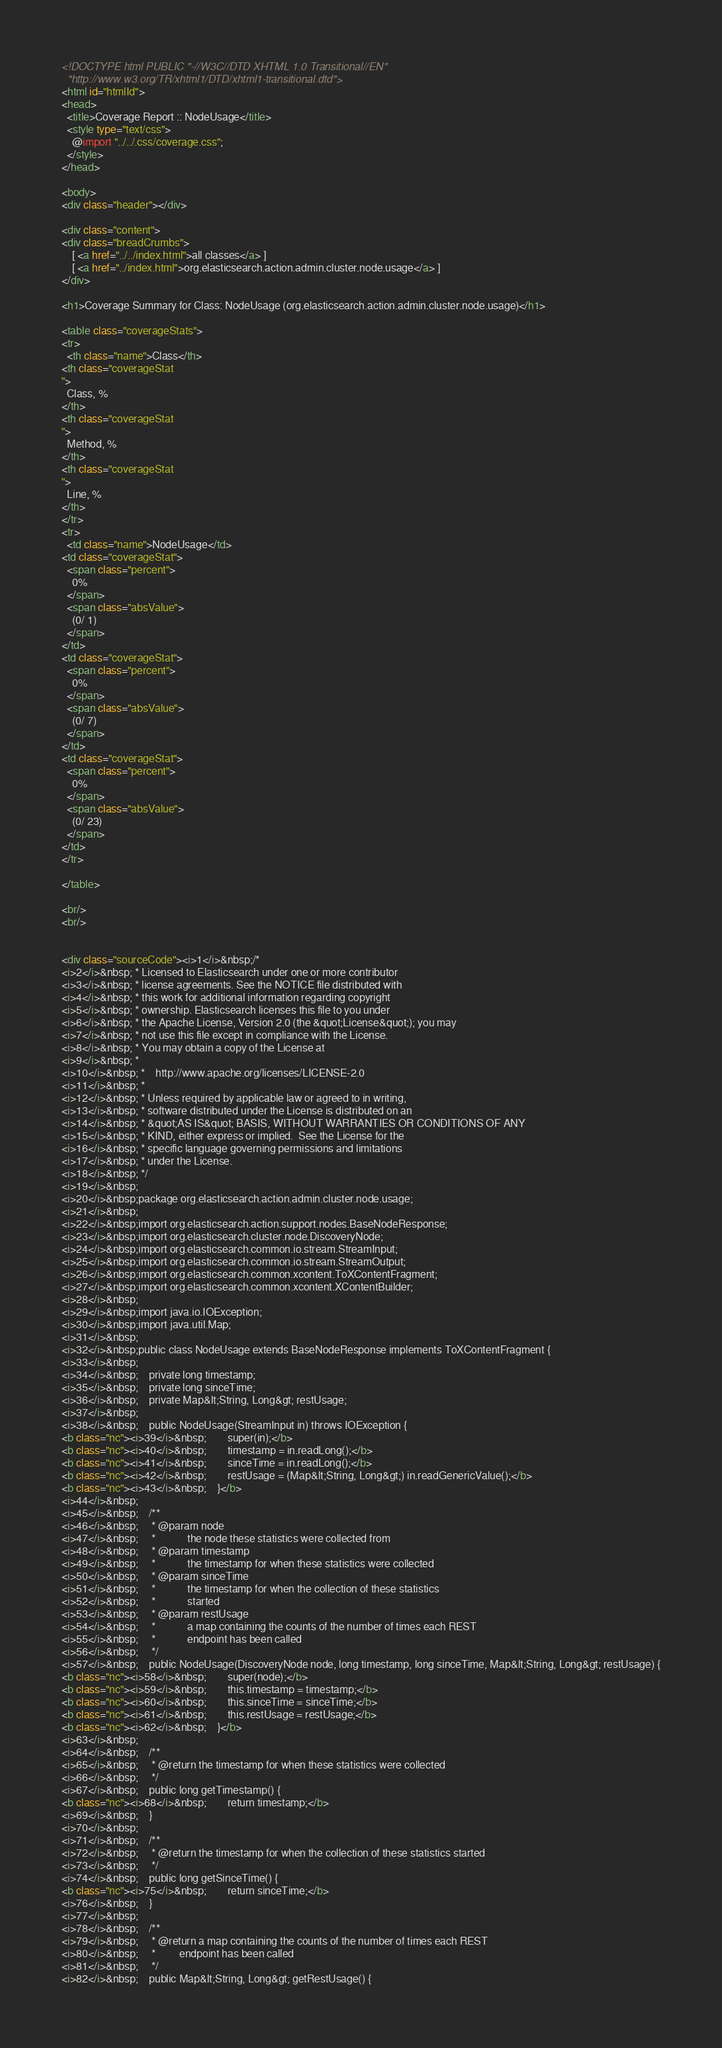<code> <loc_0><loc_0><loc_500><loc_500><_HTML_><!DOCTYPE html PUBLIC "-//W3C//DTD XHTML 1.0 Transitional//EN"
  "http://www.w3.org/TR/xhtml1/DTD/xhtml1-transitional.dtd">
<html id="htmlId">
<head>
  <title>Coverage Report :: NodeUsage</title>
  <style type="text/css">
    @import "../../.css/coverage.css";
  </style>
</head>

<body>
<div class="header"></div>

<div class="content">
<div class="breadCrumbs">
    [ <a href="../../index.html">all classes</a> ]
    [ <a href="../index.html">org.elasticsearch.action.admin.cluster.node.usage</a> ]
</div>

<h1>Coverage Summary for Class: NodeUsage (org.elasticsearch.action.admin.cluster.node.usage)</h1>

<table class="coverageStats">
<tr>
  <th class="name">Class</th>
<th class="coverageStat 
">
  Class, %
</th>
<th class="coverageStat 
">
  Method, %
</th>
<th class="coverageStat 
">
  Line, %
</th>
</tr>
<tr>
  <td class="name">NodeUsage</td>
<td class="coverageStat">
  <span class="percent">
    0%
  </span>
  <span class="absValue">
    (0/ 1)
  </span>
</td>
<td class="coverageStat">
  <span class="percent">
    0%
  </span>
  <span class="absValue">
    (0/ 7)
  </span>
</td>
<td class="coverageStat">
  <span class="percent">
    0%
  </span>
  <span class="absValue">
    (0/ 23)
  </span>
</td>
</tr>

</table>

<br/>
<br/>


<div class="sourceCode"><i>1</i>&nbsp;/*
<i>2</i>&nbsp; * Licensed to Elasticsearch under one or more contributor
<i>3</i>&nbsp; * license agreements. See the NOTICE file distributed with
<i>4</i>&nbsp; * this work for additional information regarding copyright
<i>5</i>&nbsp; * ownership. Elasticsearch licenses this file to you under
<i>6</i>&nbsp; * the Apache License, Version 2.0 (the &quot;License&quot;); you may
<i>7</i>&nbsp; * not use this file except in compliance with the License.
<i>8</i>&nbsp; * You may obtain a copy of the License at
<i>9</i>&nbsp; *
<i>10</i>&nbsp; *    http://www.apache.org/licenses/LICENSE-2.0
<i>11</i>&nbsp; *
<i>12</i>&nbsp; * Unless required by applicable law or agreed to in writing,
<i>13</i>&nbsp; * software distributed under the License is distributed on an
<i>14</i>&nbsp; * &quot;AS IS&quot; BASIS, WITHOUT WARRANTIES OR CONDITIONS OF ANY
<i>15</i>&nbsp; * KIND, either express or implied.  See the License for the
<i>16</i>&nbsp; * specific language governing permissions and limitations
<i>17</i>&nbsp; * under the License.
<i>18</i>&nbsp; */
<i>19</i>&nbsp;
<i>20</i>&nbsp;package org.elasticsearch.action.admin.cluster.node.usage;
<i>21</i>&nbsp;
<i>22</i>&nbsp;import org.elasticsearch.action.support.nodes.BaseNodeResponse;
<i>23</i>&nbsp;import org.elasticsearch.cluster.node.DiscoveryNode;
<i>24</i>&nbsp;import org.elasticsearch.common.io.stream.StreamInput;
<i>25</i>&nbsp;import org.elasticsearch.common.io.stream.StreamOutput;
<i>26</i>&nbsp;import org.elasticsearch.common.xcontent.ToXContentFragment;
<i>27</i>&nbsp;import org.elasticsearch.common.xcontent.XContentBuilder;
<i>28</i>&nbsp;
<i>29</i>&nbsp;import java.io.IOException;
<i>30</i>&nbsp;import java.util.Map;
<i>31</i>&nbsp;
<i>32</i>&nbsp;public class NodeUsage extends BaseNodeResponse implements ToXContentFragment {
<i>33</i>&nbsp;
<i>34</i>&nbsp;    private long timestamp;
<i>35</i>&nbsp;    private long sinceTime;
<i>36</i>&nbsp;    private Map&lt;String, Long&gt; restUsage;
<i>37</i>&nbsp;
<i>38</i>&nbsp;    public NodeUsage(StreamInput in) throws IOException {
<b class="nc"><i>39</i>&nbsp;        super(in);</b>
<b class="nc"><i>40</i>&nbsp;        timestamp = in.readLong();</b>
<b class="nc"><i>41</i>&nbsp;        sinceTime = in.readLong();</b>
<b class="nc"><i>42</i>&nbsp;        restUsage = (Map&lt;String, Long&gt;) in.readGenericValue();</b>
<b class="nc"><i>43</i>&nbsp;    }</b>
<i>44</i>&nbsp;
<i>45</i>&nbsp;    /**
<i>46</i>&nbsp;     * @param node
<i>47</i>&nbsp;     *            the node these statistics were collected from
<i>48</i>&nbsp;     * @param timestamp
<i>49</i>&nbsp;     *            the timestamp for when these statistics were collected
<i>50</i>&nbsp;     * @param sinceTime
<i>51</i>&nbsp;     *            the timestamp for when the collection of these statistics
<i>52</i>&nbsp;     *            started
<i>53</i>&nbsp;     * @param restUsage
<i>54</i>&nbsp;     *            a map containing the counts of the number of times each REST
<i>55</i>&nbsp;     *            endpoint has been called
<i>56</i>&nbsp;     */
<i>57</i>&nbsp;    public NodeUsage(DiscoveryNode node, long timestamp, long sinceTime, Map&lt;String, Long&gt; restUsage) {
<b class="nc"><i>58</i>&nbsp;        super(node);</b>
<b class="nc"><i>59</i>&nbsp;        this.timestamp = timestamp;</b>
<b class="nc"><i>60</i>&nbsp;        this.sinceTime = sinceTime;</b>
<b class="nc"><i>61</i>&nbsp;        this.restUsage = restUsage;</b>
<b class="nc"><i>62</i>&nbsp;    }</b>
<i>63</i>&nbsp;
<i>64</i>&nbsp;    /**
<i>65</i>&nbsp;     * @return the timestamp for when these statistics were collected
<i>66</i>&nbsp;     */
<i>67</i>&nbsp;    public long getTimestamp() {
<b class="nc"><i>68</i>&nbsp;        return timestamp;</b>
<i>69</i>&nbsp;    }
<i>70</i>&nbsp;
<i>71</i>&nbsp;    /**
<i>72</i>&nbsp;     * @return the timestamp for when the collection of these statistics started
<i>73</i>&nbsp;     */
<i>74</i>&nbsp;    public long getSinceTime() {
<b class="nc"><i>75</i>&nbsp;        return sinceTime;</b>
<i>76</i>&nbsp;    }
<i>77</i>&nbsp;
<i>78</i>&nbsp;    /**
<i>79</i>&nbsp;     * @return a map containing the counts of the number of times each REST
<i>80</i>&nbsp;     *         endpoint has been called
<i>81</i>&nbsp;     */
<i>82</i>&nbsp;    public Map&lt;String, Long&gt; getRestUsage() {</code> 